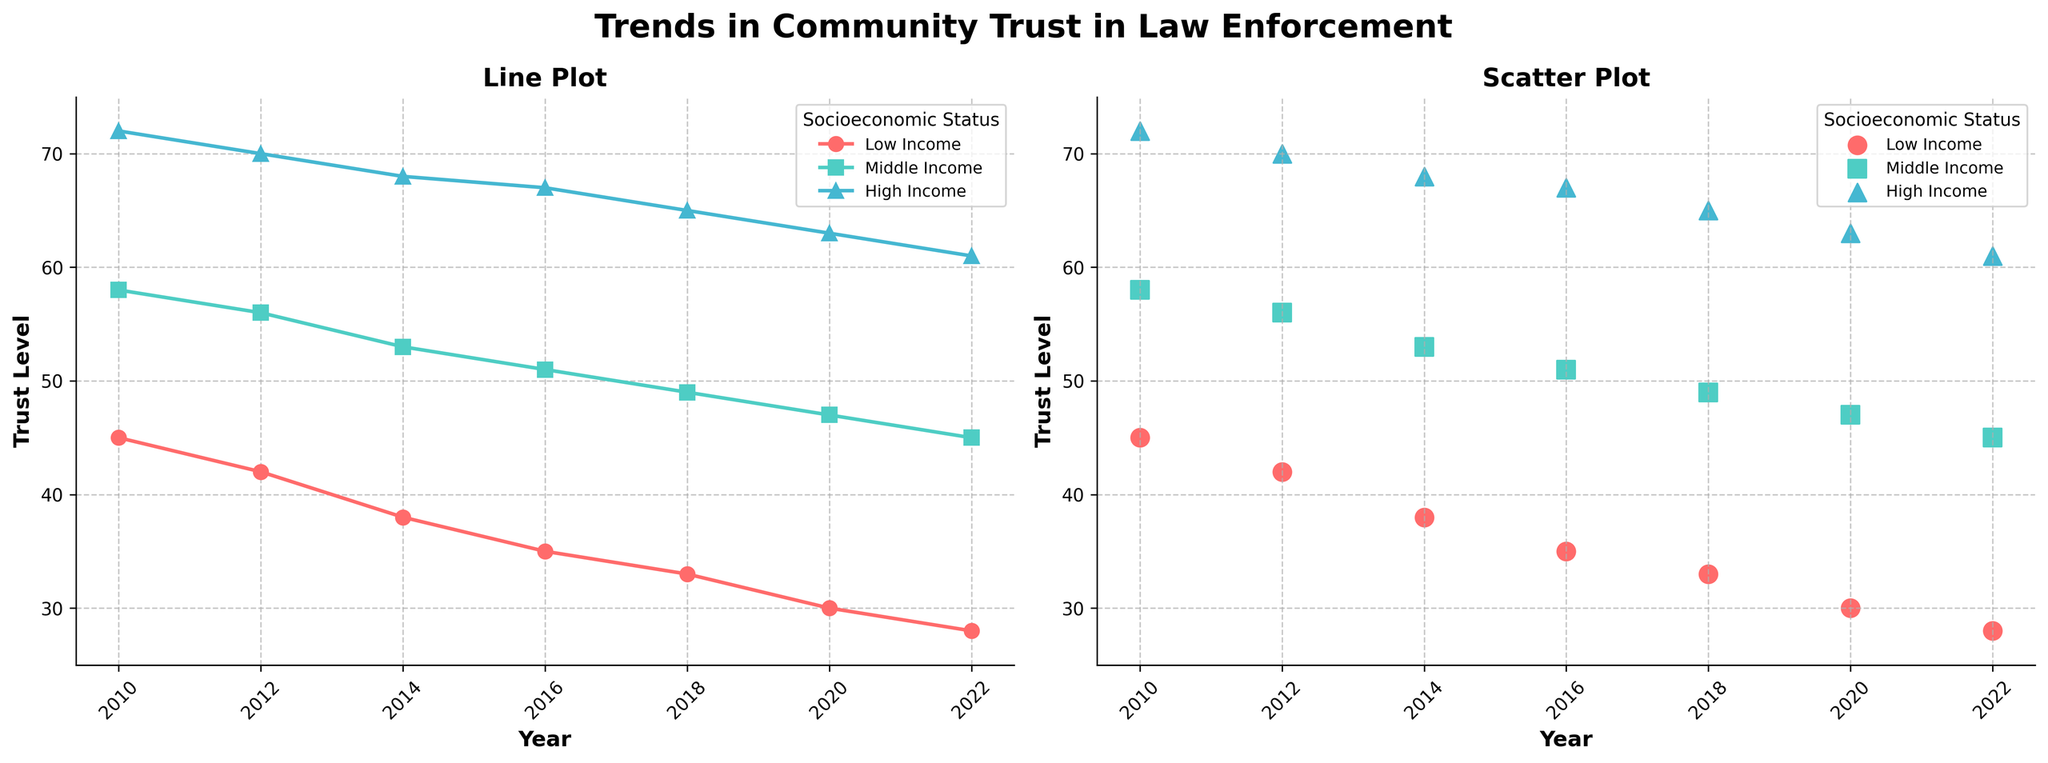What is the title of the left subplot? The title of the left subplot can be observed at the top of the left-hand side of the figure. It reads "Line Plot".
Answer: Line Plot Which socioeconomic status has the lowest trust level in 2022? By examining the data points for the year 2022 in both plots, the lowest trust level is represented by the data point closest to the y-axis's lower end for 2022. The color and the marker indicate that it is "Low Income".
Answer: Low Income How many unique years are displayed in the figure? The x-axis of both subplots shows ticks that represent unique years. Counting these ticks gives us the total number of unique years.
Answer: 7 What is the general trend of trust level in law enforcement from 2010 to 2022 for the middle-income group in the line plot? Observing the line corresponding to the middle-income group, the general trend can be identified by noting the direction (increasing or decreasing) and overall movement of the line from 2010 to 2022. The trend shows a decrease.
Answer: Decreasing What is the difference in trust levels between middle-income and high-income groups in 2020 in the scatter plot? Locate the 2020 data points for both middle-income and high-income groups in the scatter plot. The trust level for middle-income is 47 and for high-income is 63, the difference is calculated as 63 - 47.
Answer: 16 Which group shows the steepest decline in trust level from 2010 to 2022 in the line plot? By comparing the slopes of the lines for each group from 2010 to 2022, the group with the steepest decline shows the largest negative change over time. The "Low Income" group has the steepest decline.
Answer: Low Income What are the final trust levels in 2022 for all three socioeconomic statuses in the scatter plot? By observing the data points for the year 2022 in the scatter plot, the positions of each marker indicate the trust levels for "Low Income," "Middle Income," and "High Income" groups, which are 28, 45, and 61 respectively.
Answer: 28, 45, 61 What is the average trust level across all socioeconomic statuses in 2018 in the line plot? Find the values for 2018 for all three socioeconomic statuses in the line plot. These values are 33 (Low Income), 49 (Middle Income), and 65 (High Income). The average is calculated as (33 + 49 + 65) / 3.
Answer: 49 Which socioeconomic status had the highest trust level in 2010 in the scatter plot? Identify the marker for 2010 with the highest position along the y-axis in the scatter plot. The "High Income" group is at the top with a trust level of 72.
Answer: High Income 